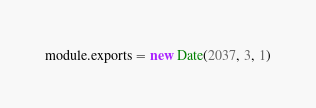Convert code to text. <code><loc_0><loc_0><loc_500><loc_500><_JavaScript_>module.exports = new Date(2037, 3, 1)
</code> 